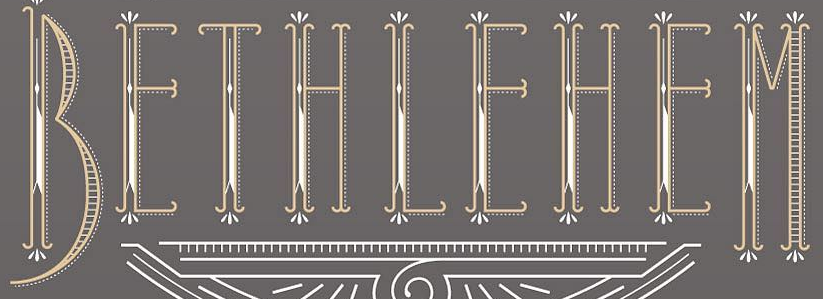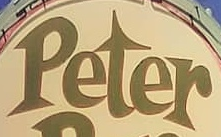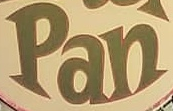What text is displayed in these images sequentially, separated by a semicolon? BEIHIEHEM; Peter; Pan 